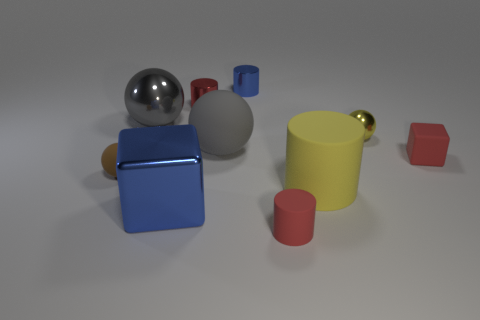Subtract all small rubber spheres. How many spheres are left? 3 Subtract all yellow balls. How many balls are left? 3 Subtract 4 cylinders. How many cylinders are left? 0 Subtract 0 cyan blocks. How many objects are left? 10 Subtract all cubes. How many objects are left? 8 Subtract all red cylinders. Subtract all cyan spheres. How many cylinders are left? 2 Subtract all purple blocks. How many purple spheres are left? 0 Subtract all rubber objects. Subtract all blue metal objects. How many objects are left? 3 Add 8 red rubber objects. How many red rubber objects are left? 10 Add 7 blue cubes. How many blue cubes exist? 8 